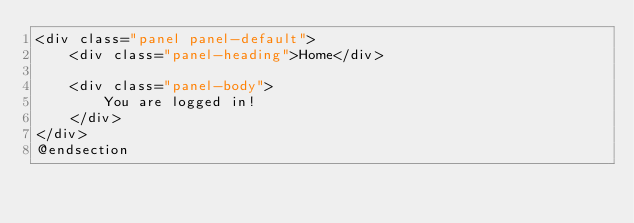<code> <loc_0><loc_0><loc_500><loc_500><_PHP_><div class="panel panel-default">
	<div class="panel-heading">Home</div>

	<div class="panel-body">
		You are logged in!
	</div>
</div>
@endsection
</code> 